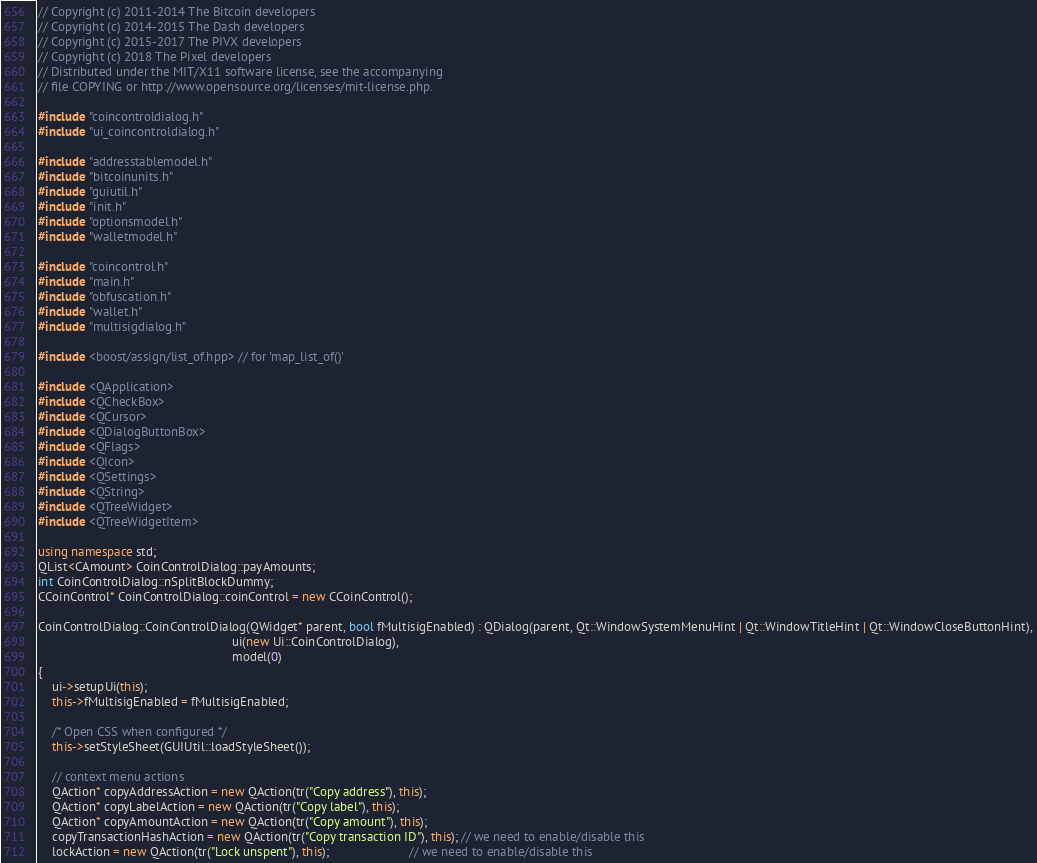<code> <loc_0><loc_0><loc_500><loc_500><_C++_>// Copyright (c) 2011-2014 The Bitcoin developers
// Copyright (c) 2014-2015 The Dash developers
// Copyright (c) 2015-2017 The PIVX developers
// Copyright (c) 2018 The Pixel developers
// Distributed under the MIT/X11 software license, see the accompanying
// file COPYING or http://www.opensource.org/licenses/mit-license.php.

#include "coincontroldialog.h"
#include "ui_coincontroldialog.h"

#include "addresstablemodel.h"
#include "bitcoinunits.h"
#include "guiutil.h"
#include "init.h"
#include "optionsmodel.h"
#include "walletmodel.h"

#include "coincontrol.h"
#include "main.h"
#include "obfuscation.h"
#include "wallet.h"
#include "multisigdialog.h"

#include <boost/assign/list_of.hpp> // for 'map_list_of()'

#include <QApplication>
#include <QCheckBox>
#include <QCursor>
#include <QDialogButtonBox>
#include <QFlags>
#include <QIcon>
#include <QSettings>
#include <QString>
#include <QTreeWidget>
#include <QTreeWidgetItem>

using namespace std;
QList<CAmount> CoinControlDialog::payAmounts;
int CoinControlDialog::nSplitBlockDummy;
CCoinControl* CoinControlDialog::coinControl = new CCoinControl();

CoinControlDialog::CoinControlDialog(QWidget* parent, bool fMultisigEnabled) : QDialog(parent, Qt::WindowSystemMenuHint | Qt::WindowTitleHint | Qt::WindowCloseButtonHint),
                                                        ui(new Ui::CoinControlDialog),
                                                        model(0)
{
    ui->setupUi(this);
    this->fMultisigEnabled = fMultisigEnabled;

    /* Open CSS when configured */
    this->setStyleSheet(GUIUtil::loadStyleSheet());

    // context menu actions
    QAction* copyAddressAction = new QAction(tr("Copy address"), this);
    QAction* copyLabelAction = new QAction(tr("Copy label"), this);
    QAction* copyAmountAction = new QAction(tr("Copy amount"), this);
    copyTransactionHashAction = new QAction(tr("Copy transaction ID"), this); // we need to enable/disable this
    lockAction = new QAction(tr("Lock unspent"), this);                       // we need to enable/disable this</code> 